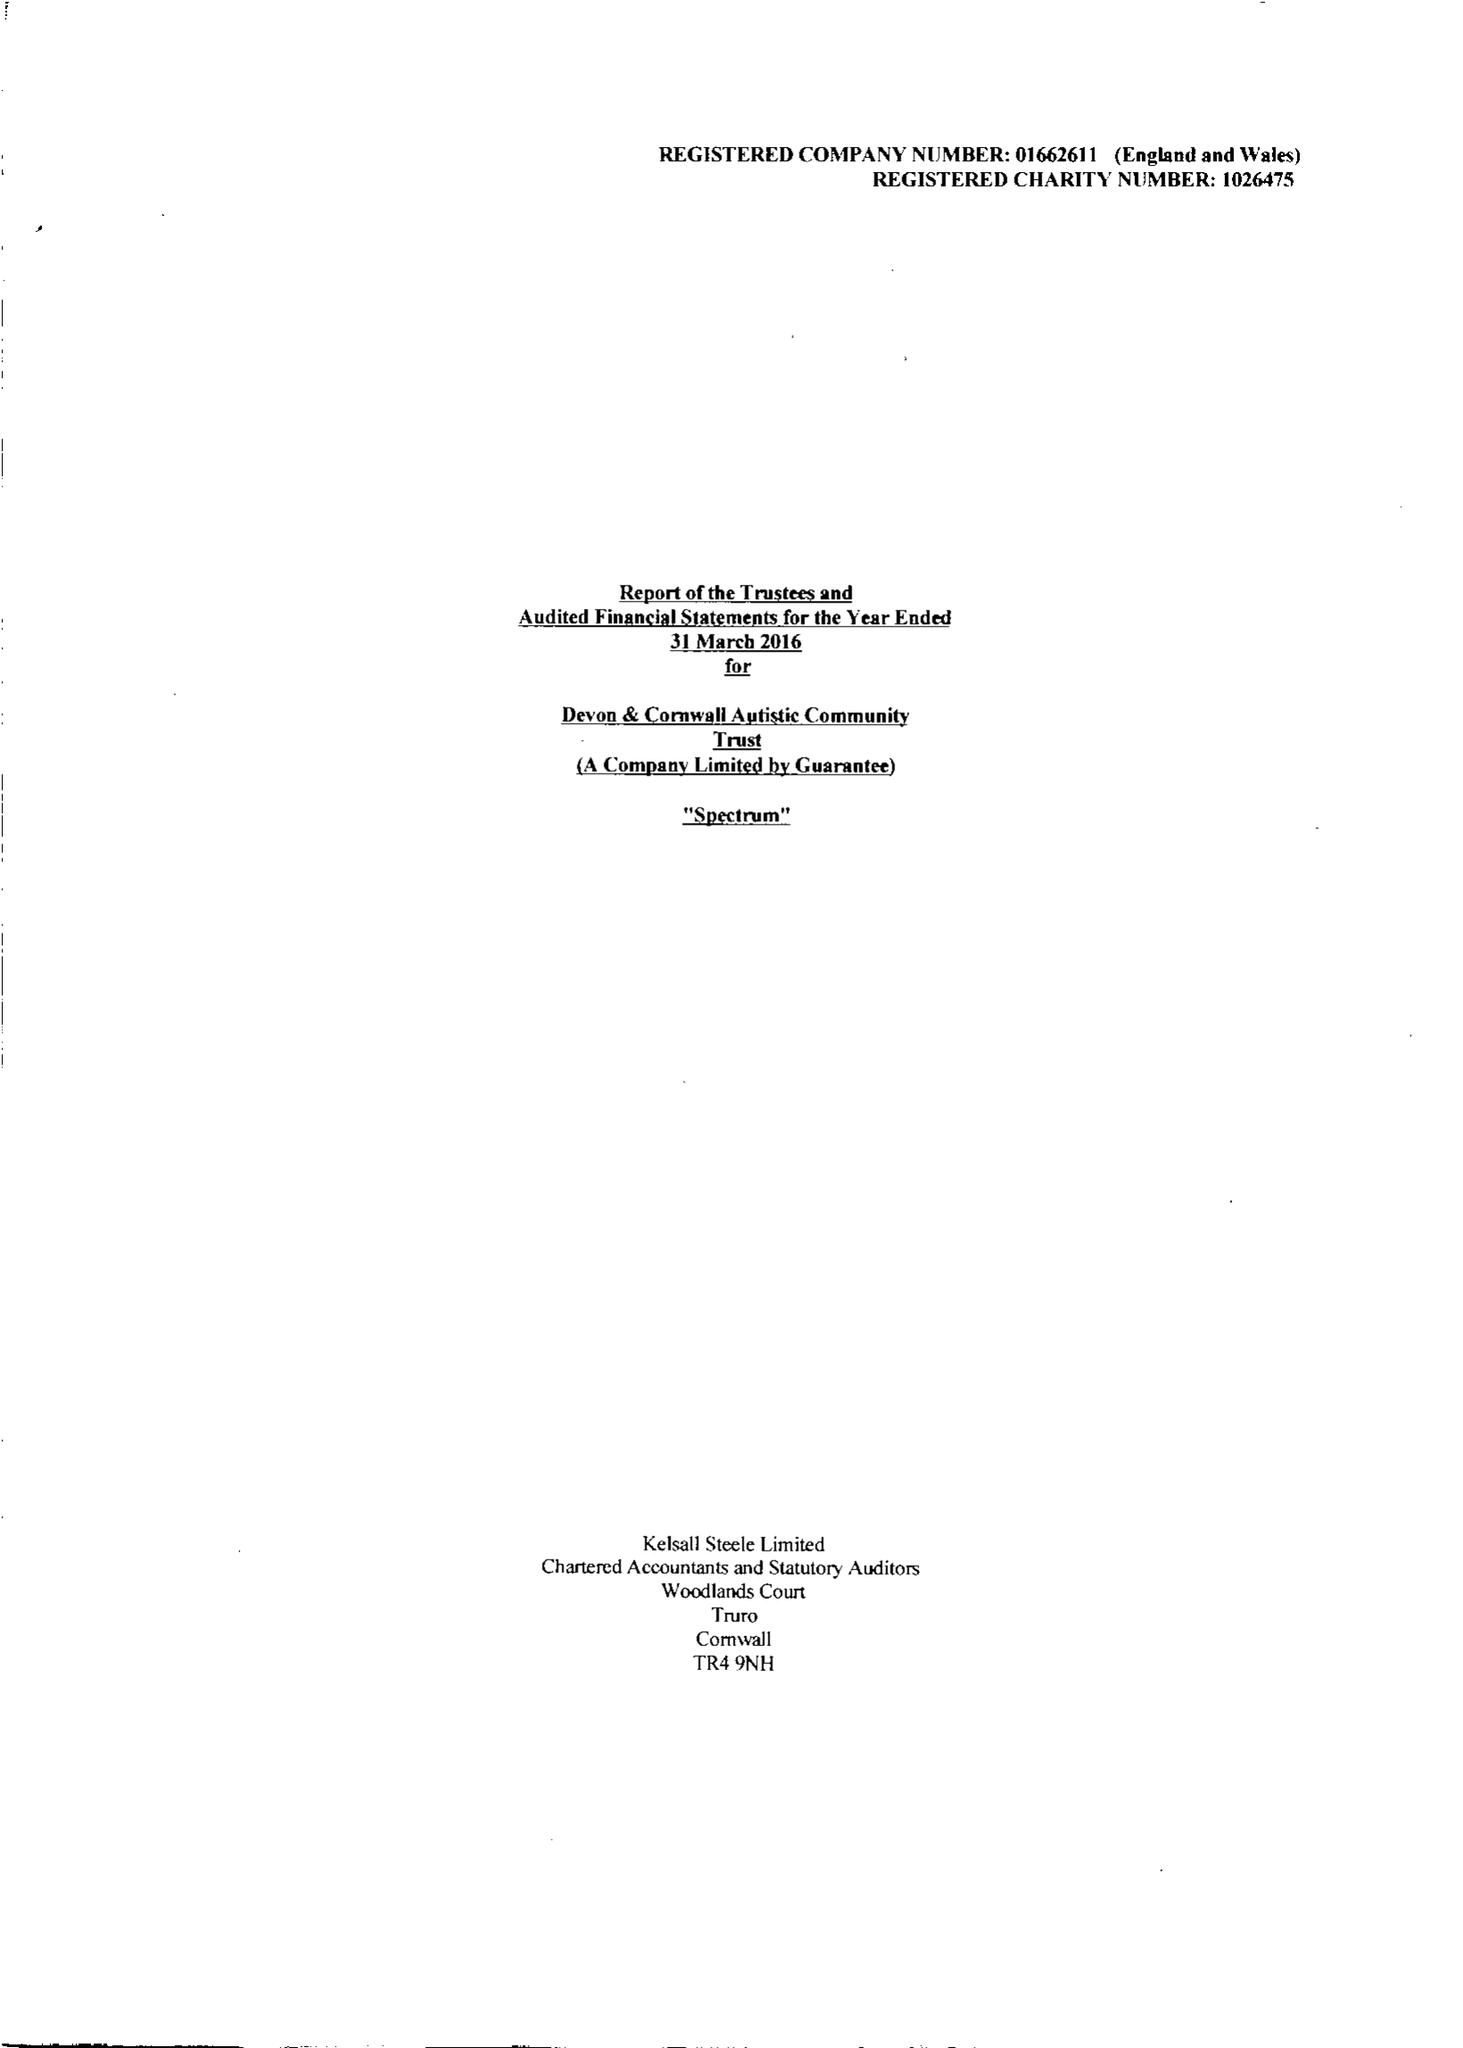What is the value for the address__street_line?
Answer the question using a single word or phrase. None 